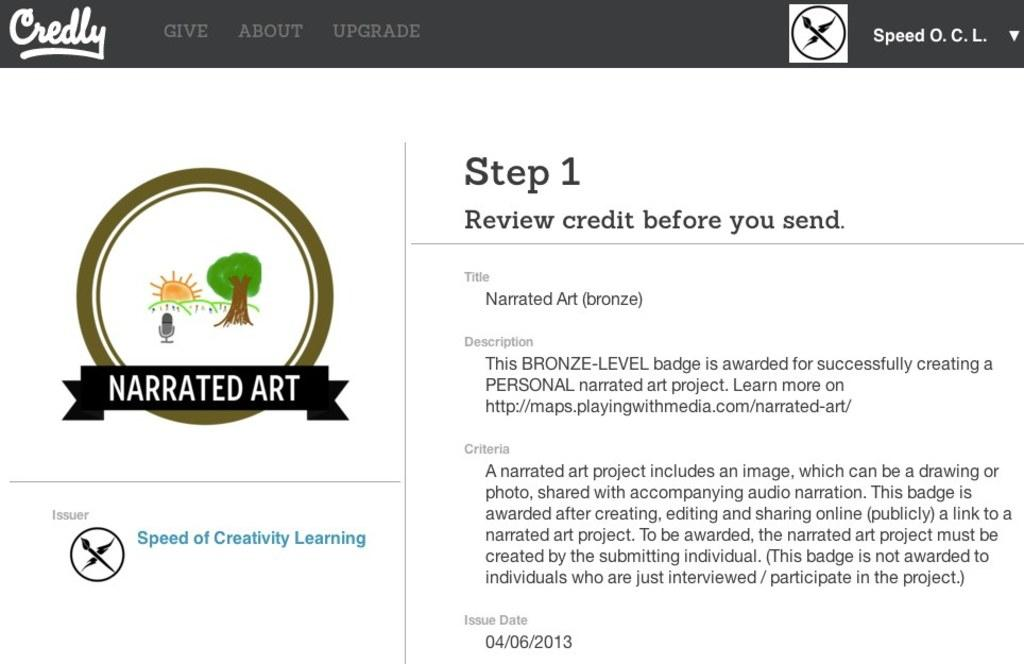What type of image is shown in the picture? There is a screenshot in the image. What can be found within the screenshot? The screenshot contains text and a date. Is there any identifying mark in the screenshot? Yes, there is a logo in the screenshot. How many bubbles are floating around the logo in the image? There are no bubbles present in the image. Is there a banana in the screenshot? No, there is no banana in the image. 